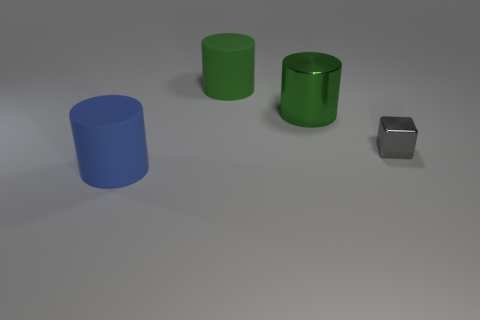Subtract all shiny cylinders. How many cylinders are left? 2 Subtract 1 cylinders. How many cylinders are left? 2 Add 3 cylinders. How many objects exist? 7 Subtract all cylinders. How many objects are left? 1 Subtract all green objects. Subtract all metallic cubes. How many objects are left? 1 Add 1 large metal cylinders. How many large metal cylinders are left? 2 Add 4 gray metal cylinders. How many gray metal cylinders exist? 4 Subtract 0 red spheres. How many objects are left? 4 